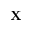Convert formula to latex. <formula><loc_0><loc_0><loc_500><loc_500>{ X }</formula> 